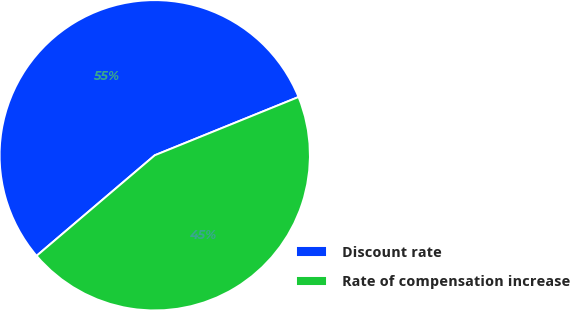<chart> <loc_0><loc_0><loc_500><loc_500><pie_chart><fcel>Discount rate<fcel>Rate of compensation increase<nl><fcel>55.09%<fcel>44.91%<nl></chart> 